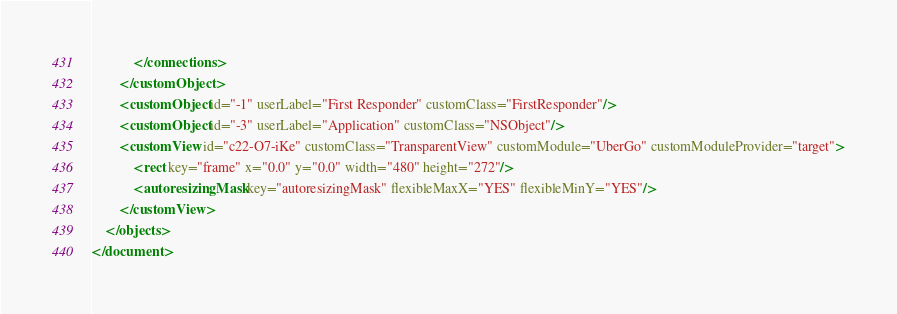<code> <loc_0><loc_0><loc_500><loc_500><_XML_>            </connections>
        </customObject>
        <customObject id="-1" userLabel="First Responder" customClass="FirstResponder"/>
        <customObject id="-3" userLabel="Application" customClass="NSObject"/>
        <customView id="c22-O7-iKe" customClass="TransparentView" customModule="UberGo" customModuleProvider="target">
            <rect key="frame" x="0.0" y="0.0" width="480" height="272"/>
            <autoresizingMask key="autoresizingMask" flexibleMaxX="YES" flexibleMinY="YES"/>
        </customView>
    </objects>
</document>
</code> 